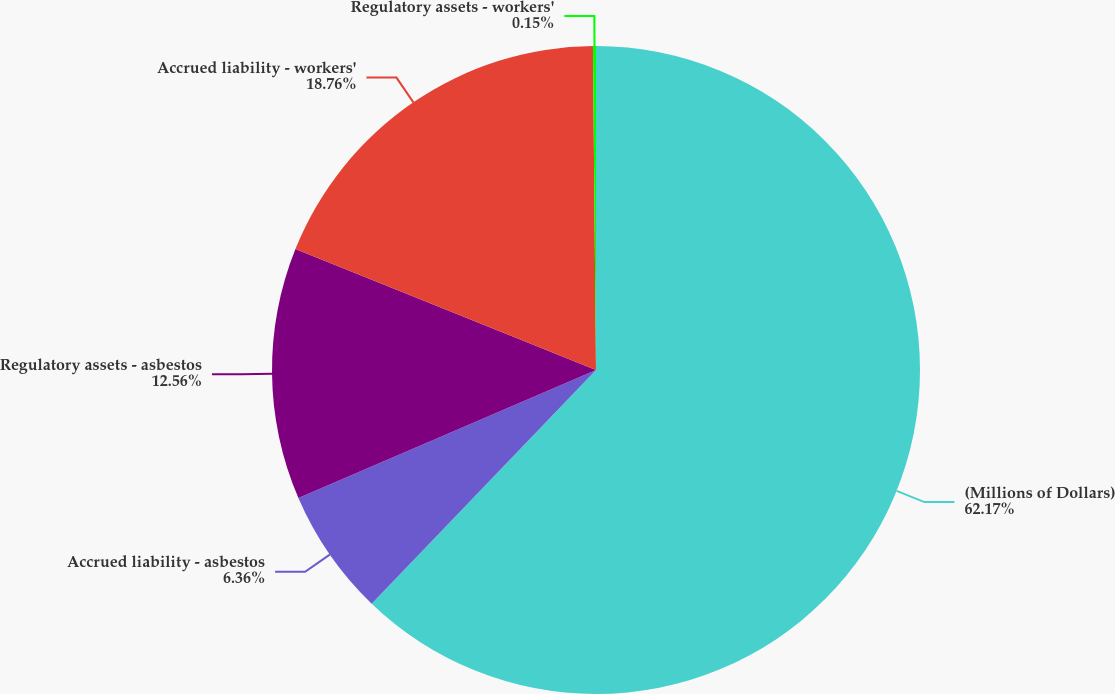<chart> <loc_0><loc_0><loc_500><loc_500><pie_chart><fcel>(Millions of Dollars)<fcel>Accrued liability - asbestos<fcel>Regulatory assets - asbestos<fcel>Accrued liability - workers'<fcel>Regulatory assets - workers'<nl><fcel>62.17%<fcel>6.36%<fcel>12.56%<fcel>18.76%<fcel>0.15%<nl></chart> 